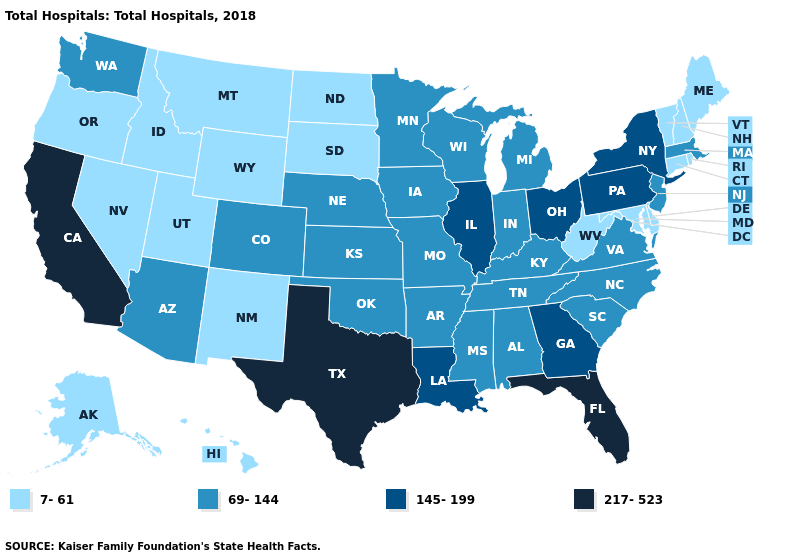Name the states that have a value in the range 69-144?
Answer briefly. Alabama, Arizona, Arkansas, Colorado, Indiana, Iowa, Kansas, Kentucky, Massachusetts, Michigan, Minnesota, Mississippi, Missouri, Nebraska, New Jersey, North Carolina, Oklahoma, South Carolina, Tennessee, Virginia, Washington, Wisconsin. Which states have the lowest value in the MidWest?
Keep it brief. North Dakota, South Dakota. What is the lowest value in states that border South Carolina?
Concise answer only. 69-144. Name the states that have a value in the range 7-61?
Keep it brief. Alaska, Connecticut, Delaware, Hawaii, Idaho, Maine, Maryland, Montana, Nevada, New Hampshire, New Mexico, North Dakota, Oregon, Rhode Island, South Dakota, Utah, Vermont, West Virginia, Wyoming. Among the states that border Minnesota , which have the highest value?
Give a very brief answer. Iowa, Wisconsin. Which states have the lowest value in the USA?
Write a very short answer. Alaska, Connecticut, Delaware, Hawaii, Idaho, Maine, Maryland, Montana, Nevada, New Hampshire, New Mexico, North Dakota, Oregon, Rhode Island, South Dakota, Utah, Vermont, West Virginia, Wyoming. What is the value of Wyoming?
Concise answer only. 7-61. Which states have the highest value in the USA?
Be succinct. California, Florida, Texas. What is the lowest value in states that border Washington?
Answer briefly. 7-61. What is the value of Louisiana?
Short answer required. 145-199. Which states have the lowest value in the Northeast?
Keep it brief. Connecticut, Maine, New Hampshire, Rhode Island, Vermont. Name the states that have a value in the range 69-144?
Write a very short answer. Alabama, Arizona, Arkansas, Colorado, Indiana, Iowa, Kansas, Kentucky, Massachusetts, Michigan, Minnesota, Mississippi, Missouri, Nebraska, New Jersey, North Carolina, Oklahoma, South Carolina, Tennessee, Virginia, Washington, Wisconsin. Is the legend a continuous bar?
Concise answer only. No. What is the value of Nevada?
Short answer required. 7-61. What is the value of Alabama?
Keep it brief. 69-144. 